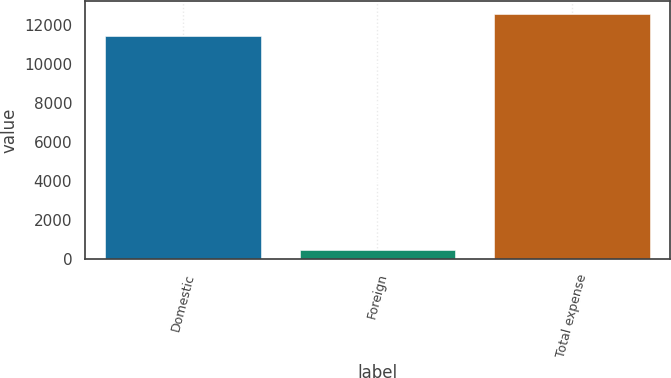Convert chart to OTSL. <chart><loc_0><loc_0><loc_500><loc_500><bar_chart><fcel>Domestic<fcel>Foreign<fcel>Total expense<nl><fcel>11448<fcel>469<fcel>12592.8<nl></chart> 